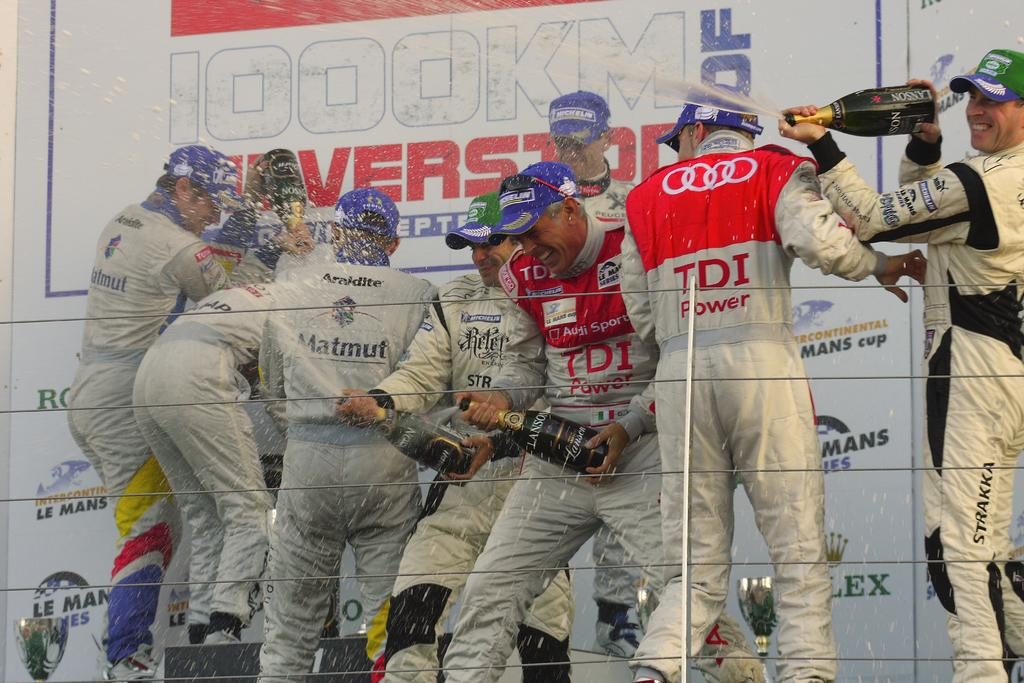<image>
Share a concise interpretation of the image provided. The crew of the TDI Power team spray champagne all over each other. 